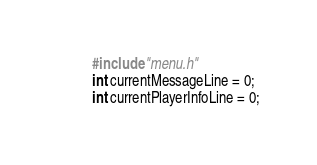Convert code to text. <code><loc_0><loc_0><loc_500><loc_500><_C_>#include "menu.h"
int currentMessageLine = 0;
int currentPlayerInfoLine = 0;</code> 